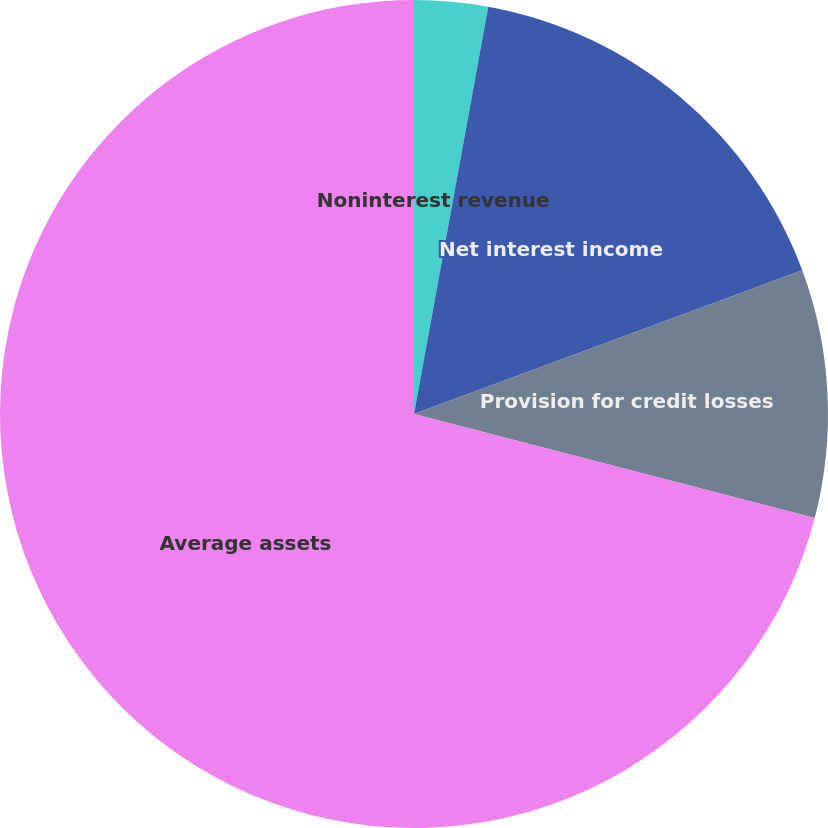Convert chart to OTSL. <chart><loc_0><loc_0><loc_500><loc_500><pie_chart><fcel>Noninterest revenue<fcel>Net interest income<fcel>Provision for credit losses<fcel>Average assets<nl><fcel>2.87%<fcel>16.49%<fcel>9.68%<fcel>70.96%<nl></chart> 